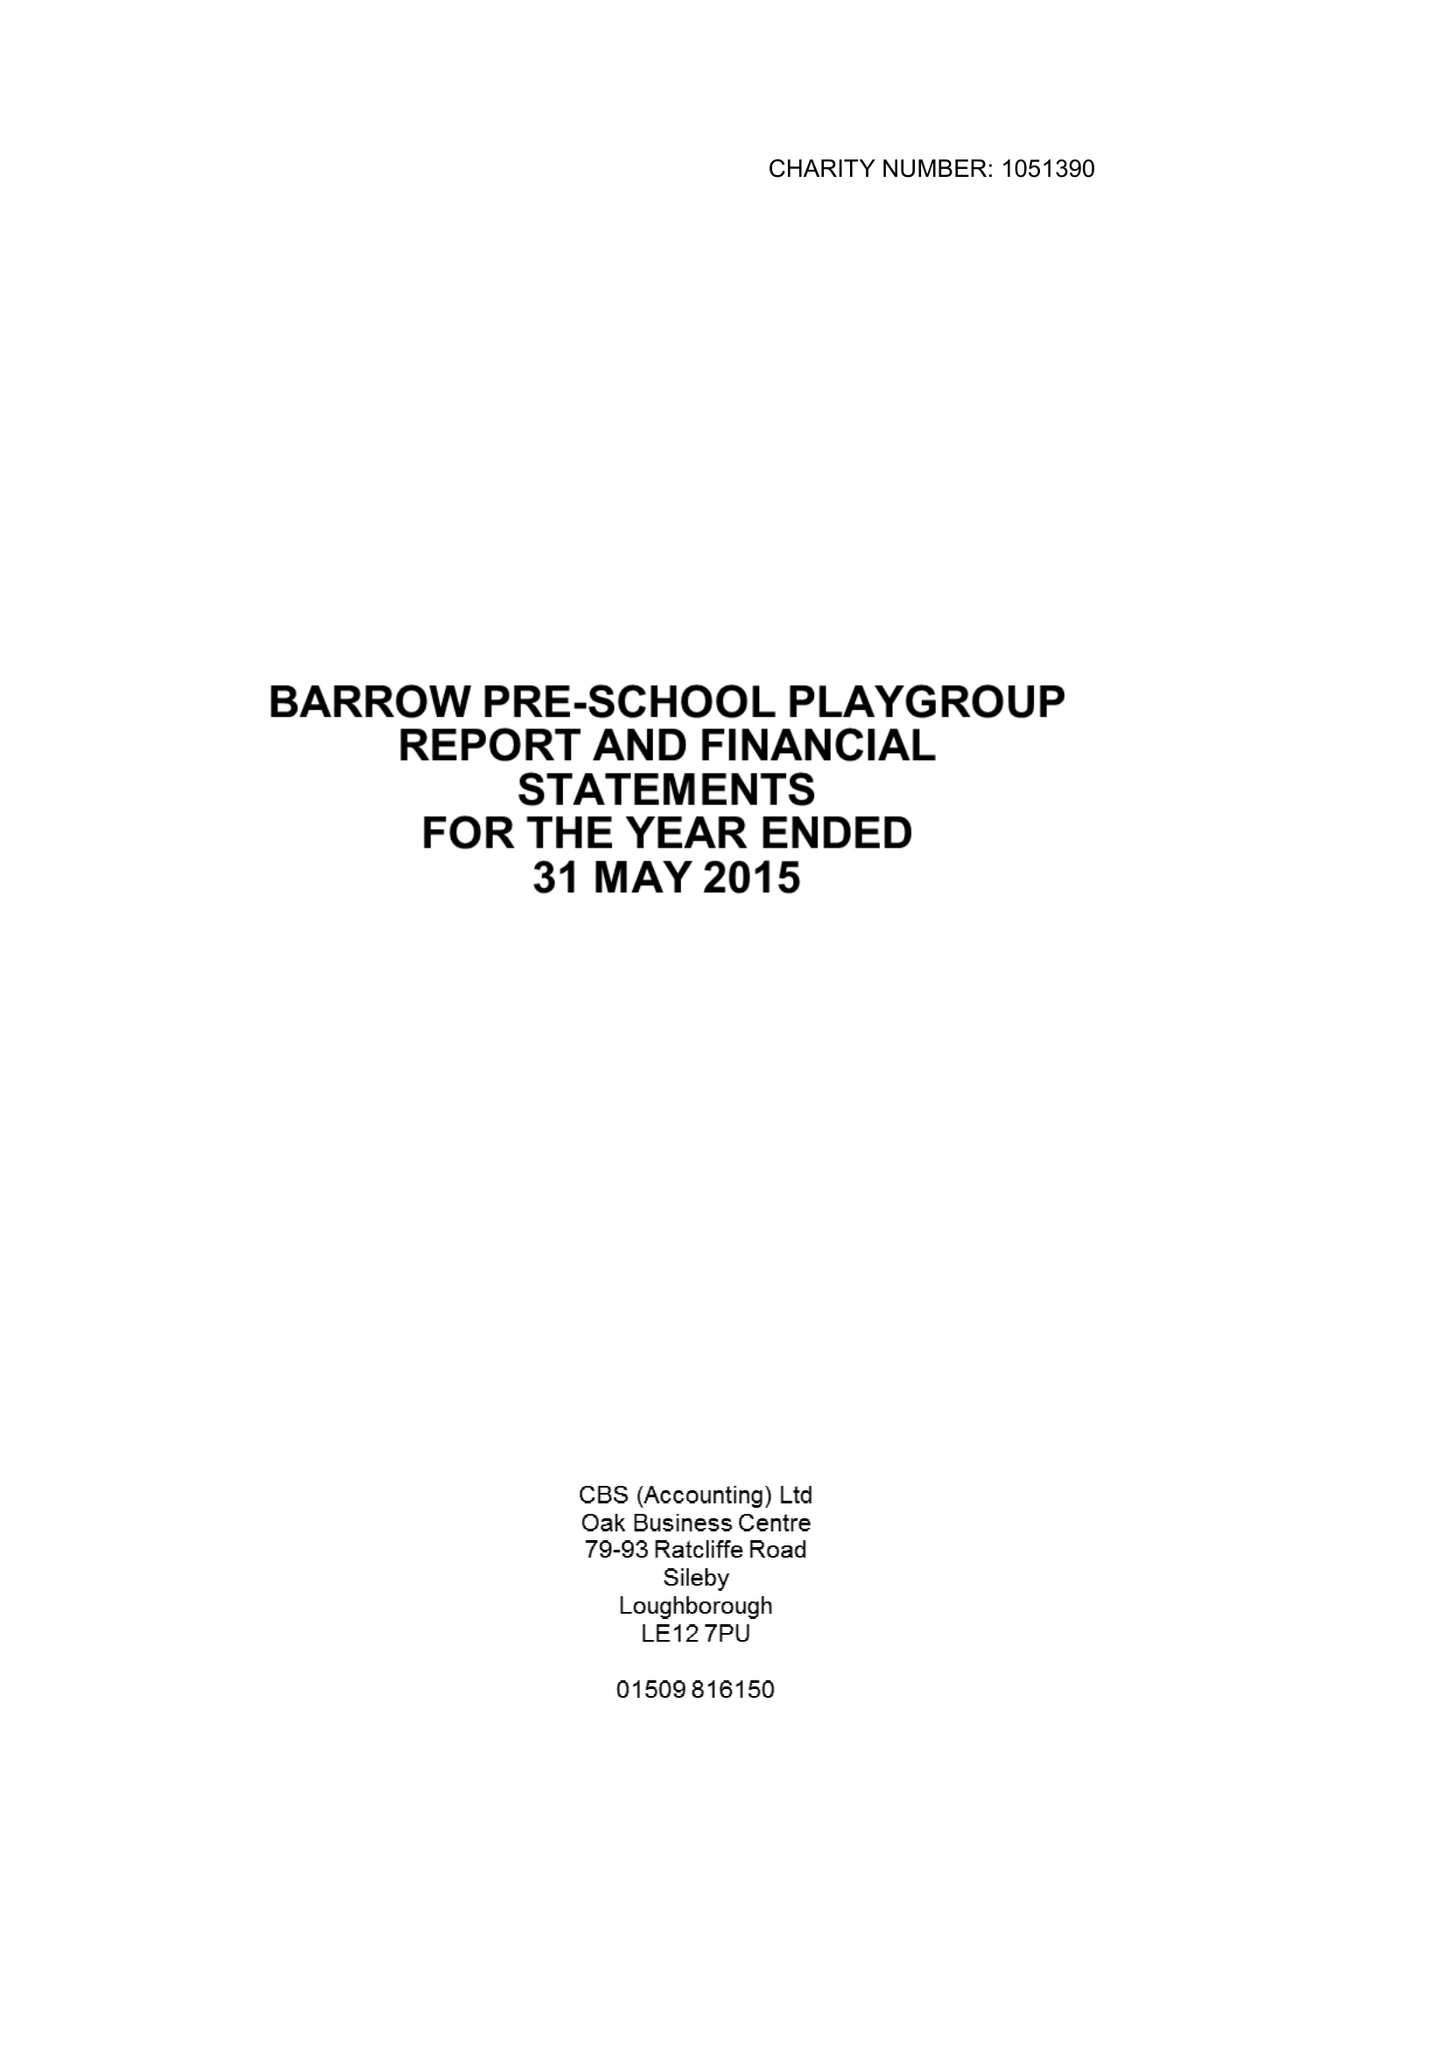What is the value for the spending_annually_in_british_pounds?
Answer the question using a single word or phrase. 58798.00 